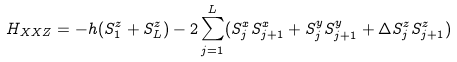Convert formula to latex. <formula><loc_0><loc_0><loc_500><loc_500>H _ { X X Z } = - h ( S ^ { z } _ { 1 } + S ^ { z } _ { L } ) - 2 \sum ^ { L } _ { j = 1 } ( S ^ { x } _ { j } S ^ { x } _ { j + 1 } + S ^ { y } _ { j } S ^ { y } _ { j + 1 } + \Delta S ^ { z } _ { j } S ^ { z } _ { j + 1 } )</formula> 